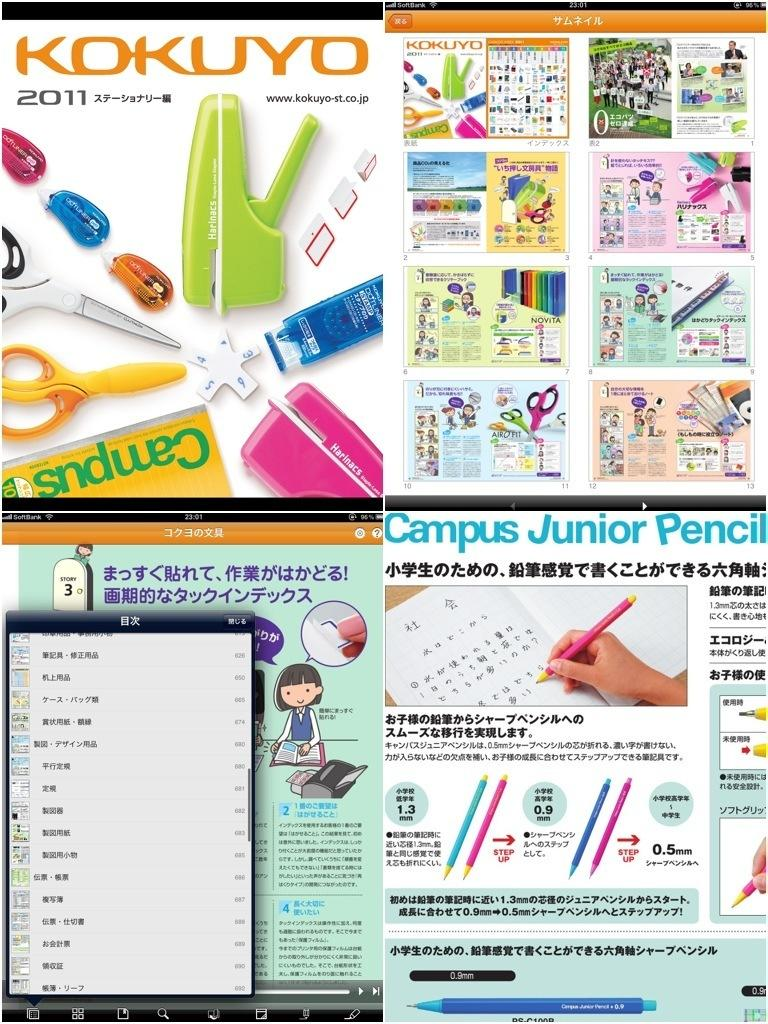<image>
Render a clear and concise summary of the photo. Posters with Chinese symbols are advertising school supplies such as a Campus Junior Pencil. 